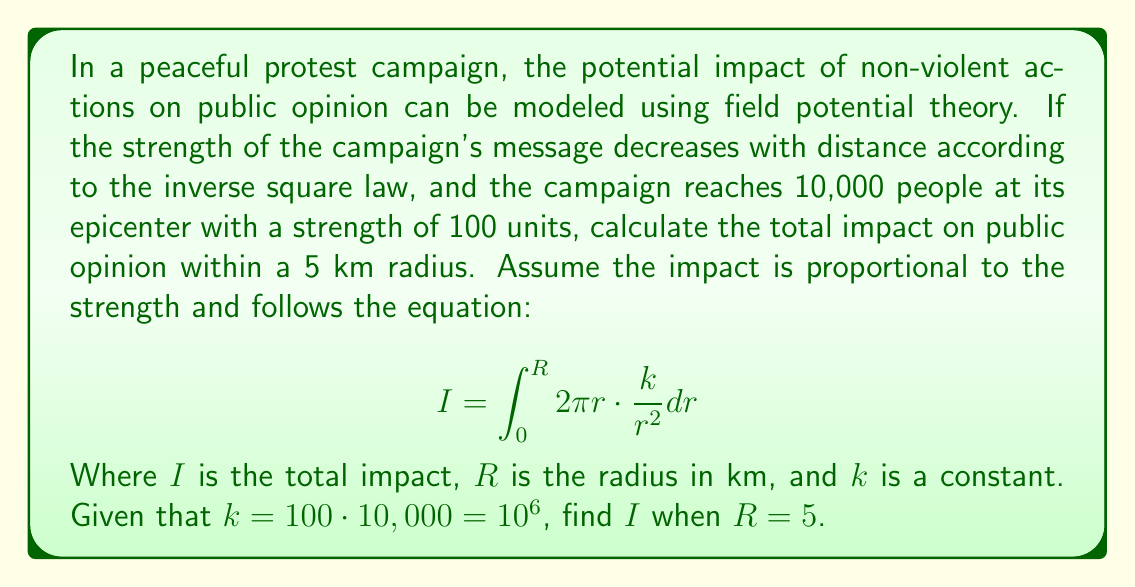Can you answer this question? To solve this problem, we'll follow these steps:

1) We start with the given equation:
   $$ I = \int_0^R 2\pi r \cdot \frac{k}{r^2} dr $$

2) Substitute the known values:
   $k = 10^6$ and $R = 5$

3) Simplify the integrand:
   $$ I = \int_0^5 2\pi \cdot \frac{10^6}{r} dr $$

4) Factor out the constants:
   $$ I = 2\pi \cdot 10^6 \int_0^5 \frac{1}{r} dr $$

5) Integrate:
   $$ I = 2\pi \cdot 10^6 [\ln r]_0^5 $$

6) Evaluate the definite integral:
   $$ I = 2\pi \cdot 10^6 (\ln 5 - \ln 0) $$

7) Note that $\ln 0$ is undefined, but we can interpret this as the limit as $r$ approaches 0. In this case, the impact would approach infinity at the epicenter, which isn't physically realistic. In practice, we would need to introduce a small constant to avoid this singularity. For this problem, we'll assume the integration starts from a small distance, say 0.01 km, instead of 0.

8) Recalculate:
   $$ I = 2\pi \cdot 10^6 (\ln 5 - \ln 0.01) $$
   $$ I = 2\pi \cdot 10^6 (\ln 500) $$

9) Calculate the final result:
   $$ I \approx 2\pi \cdot 10^6 \cdot 6.2146 \approx 39.0584 \cdot 10^6 $$

Therefore, the total impact on public opinion within a 5 km radius is approximately 39.0584 million units.
Answer: $39.0584 \cdot 10^6$ units 